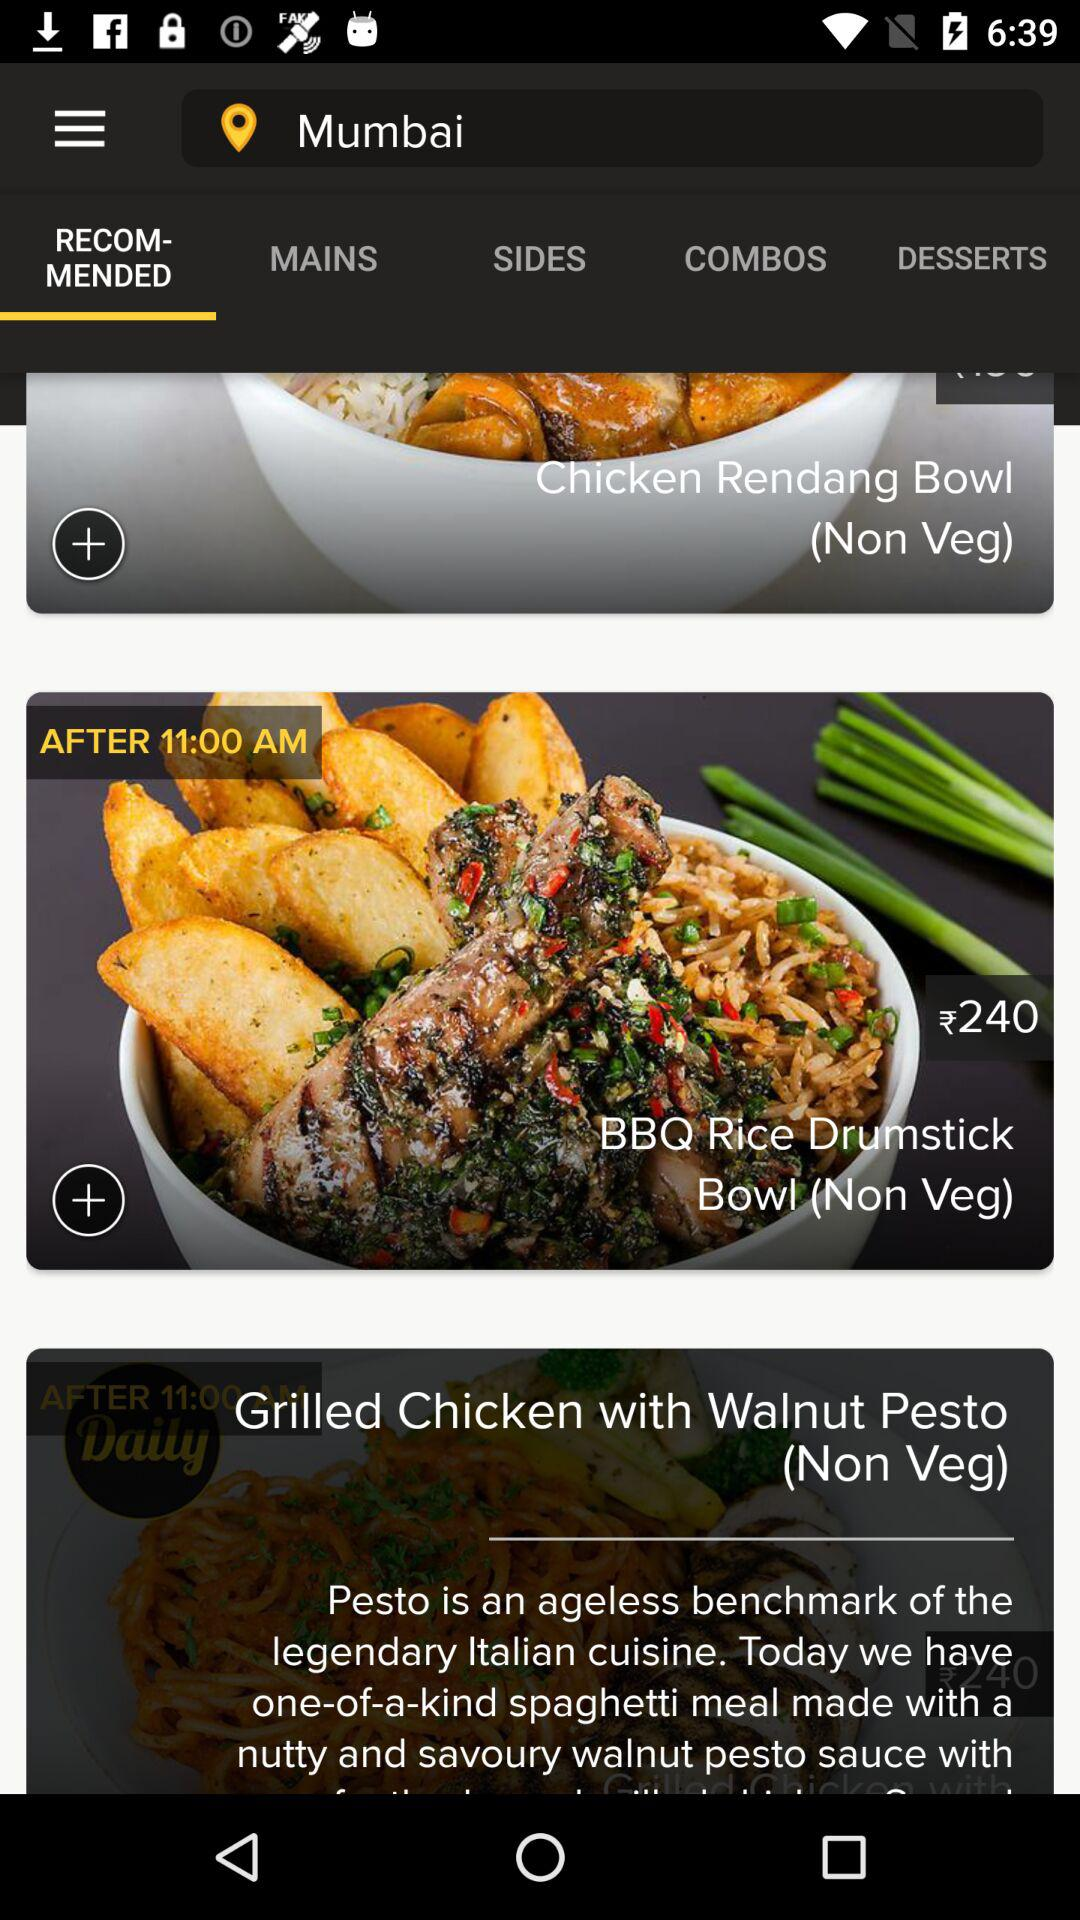Which city is selected? The selected city is Mumbai. 